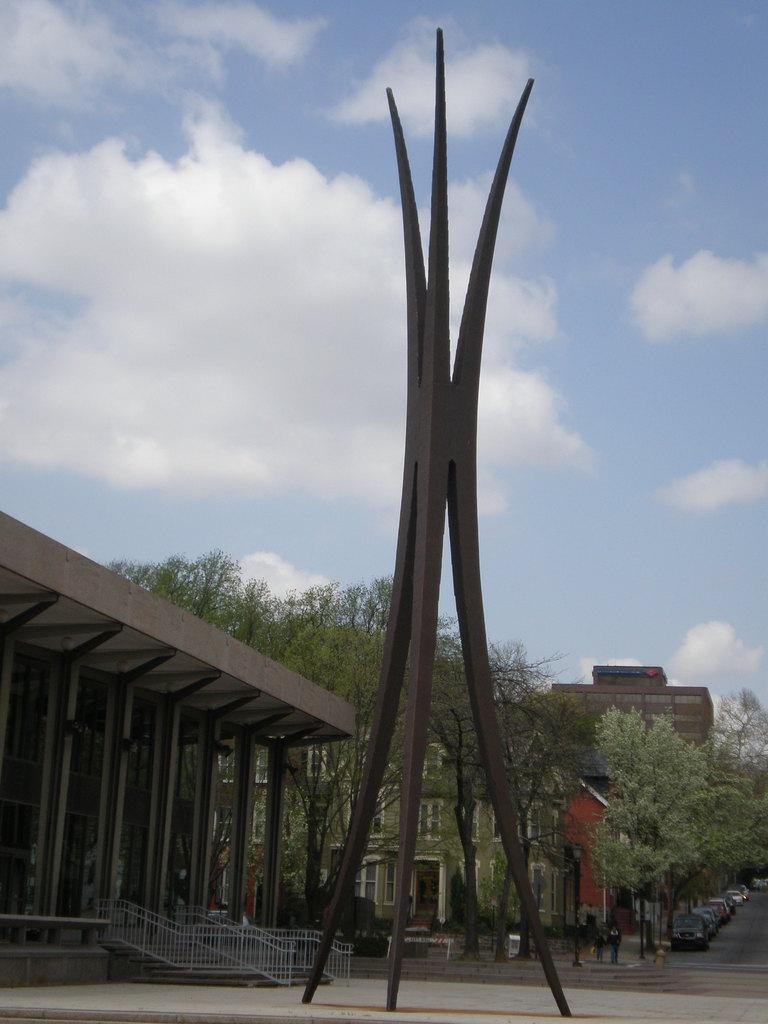What can be seen on the road in the image? There are three poles and cars on the road in the image. What is visible in the background of the image? There are buildings, trees, and the sky visible in the background of the image. What is the condition of the sky in the image? The sky is visible at the top of the image, and clouds are present in the sky. What type of insurance is being offered by the poles in the image? There is no indication of insurance being offered by the poles in the image; they are simply poles on the road. How does the distribution of cars on the road affect the route in the image? The image does not show any specific route, and the distribution of cars on the road does not affect any route. 